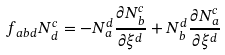Convert formula to latex. <formula><loc_0><loc_0><loc_500><loc_500>f _ { a b d } N _ { d } ^ { c } = - N _ { a } ^ { d } \frac { \partial N _ { b } ^ { c } } { \partial \xi ^ { d } } + N _ { b } ^ { d } \frac { \partial N _ { a } ^ { c } } { \partial \xi ^ { d } }</formula> 